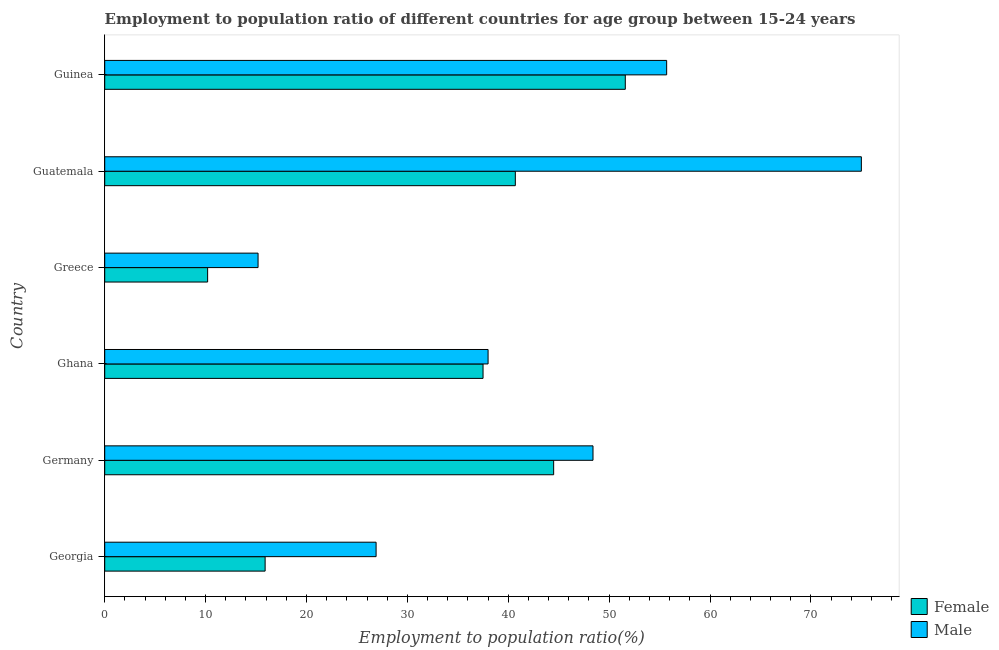Are the number of bars per tick equal to the number of legend labels?
Provide a succinct answer. Yes. What is the label of the 2nd group of bars from the top?
Keep it short and to the point. Guatemala. What is the employment to population ratio(female) in Guatemala?
Provide a succinct answer. 40.7. Across all countries, what is the maximum employment to population ratio(female)?
Keep it short and to the point. 51.6. Across all countries, what is the minimum employment to population ratio(male)?
Keep it short and to the point. 15.2. In which country was the employment to population ratio(male) maximum?
Keep it short and to the point. Guatemala. What is the total employment to population ratio(female) in the graph?
Your response must be concise. 200.4. What is the difference between the employment to population ratio(male) in Greece and that in Guatemala?
Your answer should be compact. -59.8. What is the difference between the employment to population ratio(female) in Georgia and the employment to population ratio(male) in Germany?
Offer a very short reply. -32.5. What is the average employment to population ratio(male) per country?
Offer a terse response. 43.2. What is the difference between the employment to population ratio(male) and employment to population ratio(female) in Germany?
Ensure brevity in your answer.  3.9. In how many countries, is the employment to population ratio(male) greater than 50 %?
Keep it short and to the point. 2. What is the ratio of the employment to population ratio(female) in Georgia to that in Greece?
Give a very brief answer. 1.56. Is the employment to population ratio(female) in Georgia less than that in Guinea?
Your answer should be compact. Yes. Is the difference between the employment to population ratio(male) in Ghana and Guatemala greater than the difference between the employment to population ratio(female) in Ghana and Guatemala?
Your answer should be compact. No. What is the difference between the highest and the second highest employment to population ratio(male)?
Keep it short and to the point. 19.3. What is the difference between the highest and the lowest employment to population ratio(male)?
Your response must be concise. 59.8. Is the sum of the employment to population ratio(male) in Georgia and Greece greater than the maximum employment to population ratio(female) across all countries?
Your response must be concise. No. What does the 2nd bar from the top in Germany represents?
Keep it short and to the point. Female. What does the 1st bar from the bottom in Ghana represents?
Give a very brief answer. Female. How many countries are there in the graph?
Your response must be concise. 6. What is the difference between two consecutive major ticks on the X-axis?
Keep it short and to the point. 10. Does the graph contain grids?
Offer a very short reply. No. How are the legend labels stacked?
Your answer should be very brief. Vertical. What is the title of the graph?
Give a very brief answer. Employment to population ratio of different countries for age group between 15-24 years. Does "Register a property" appear as one of the legend labels in the graph?
Provide a succinct answer. No. What is the label or title of the X-axis?
Your answer should be very brief. Employment to population ratio(%). What is the label or title of the Y-axis?
Give a very brief answer. Country. What is the Employment to population ratio(%) of Female in Georgia?
Ensure brevity in your answer.  15.9. What is the Employment to population ratio(%) in Male in Georgia?
Offer a terse response. 26.9. What is the Employment to population ratio(%) of Female in Germany?
Your response must be concise. 44.5. What is the Employment to population ratio(%) in Male in Germany?
Keep it short and to the point. 48.4. What is the Employment to population ratio(%) of Female in Ghana?
Your answer should be compact. 37.5. What is the Employment to population ratio(%) of Male in Ghana?
Your answer should be compact. 38. What is the Employment to population ratio(%) in Female in Greece?
Make the answer very short. 10.2. What is the Employment to population ratio(%) of Male in Greece?
Ensure brevity in your answer.  15.2. What is the Employment to population ratio(%) in Female in Guatemala?
Your response must be concise. 40.7. What is the Employment to population ratio(%) in Male in Guatemala?
Offer a very short reply. 75. What is the Employment to population ratio(%) in Female in Guinea?
Ensure brevity in your answer.  51.6. What is the Employment to population ratio(%) in Male in Guinea?
Provide a succinct answer. 55.7. Across all countries, what is the maximum Employment to population ratio(%) of Female?
Your response must be concise. 51.6. Across all countries, what is the minimum Employment to population ratio(%) of Female?
Ensure brevity in your answer.  10.2. Across all countries, what is the minimum Employment to population ratio(%) in Male?
Ensure brevity in your answer.  15.2. What is the total Employment to population ratio(%) in Female in the graph?
Provide a succinct answer. 200.4. What is the total Employment to population ratio(%) in Male in the graph?
Make the answer very short. 259.2. What is the difference between the Employment to population ratio(%) of Female in Georgia and that in Germany?
Your response must be concise. -28.6. What is the difference between the Employment to population ratio(%) of Male in Georgia and that in Germany?
Provide a succinct answer. -21.5. What is the difference between the Employment to population ratio(%) of Female in Georgia and that in Ghana?
Ensure brevity in your answer.  -21.6. What is the difference between the Employment to population ratio(%) in Male in Georgia and that in Ghana?
Keep it short and to the point. -11.1. What is the difference between the Employment to population ratio(%) of Male in Georgia and that in Greece?
Offer a very short reply. 11.7. What is the difference between the Employment to population ratio(%) of Female in Georgia and that in Guatemala?
Offer a terse response. -24.8. What is the difference between the Employment to population ratio(%) in Male in Georgia and that in Guatemala?
Your response must be concise. -48.1. What is the difference between the Employment to population ratio(%) in Female in Georgia and that in Guinea?
Offer a very short reply. -35.7. What is the difference between the Employment to population ratio(%) in Male in Georgia and that in Guinea?
Offer a terse response. -28.8. What is the difference between the Employment to population ratio(%) in Female in Germany and that in Ghana?
Give a very brief answer. 7. What is the difference between the Employment to population ratio(%) of Male in Germany and that in Ghana?
Offer a very short reply. 10.4. What is the difference between the Employment to population ratio(%) of Female in Germany and that in Greece?
Provide a short and direct response. 34.3. What is the difference between the Employment to population ratio(%) in Male in Germany and that in Greece?
Provide a short and direct response. 33.2. What is the difference between the Employment to population ratio(%) in Female in Germany and that in Guatemala?
Provide a short and direct response. 3.8. What is the difference between the Employment to population ratio(%) of Male in Germany and that in Guatemala?
Keep it short and to the point. -26.6. What is the difference between the Employment to population ratio(%) of Female in Germany and that in Guinea?
Your answer should be very brief. -7.1. What is the difference between the Employment to population ratio(%) in Male in Germany and that in Guinea?
Make the answer very short. -7.3. What is the difference between the Employment to population ratio(%) of Female in Ghana and that in Greece?
Ensure brevity in your answer.  27.3. What is the difference between the Employment to population ratio(%) in Male in Ghana and that in Greece?
Ensure brevity in your answer.  22.8. What is the difference between the Employment to population ratio(%) in Female in Ghana and that in Guatemala?
Your answer should be very brief. -3.2. What is the difference between the Employment to population ratio(%) in Male in Ghana and that in Guatemala?
Your response must be concise. -37. What is the difference between the Employment to population ratio(%) in Female in Ghana and that in Guinea?
Keep it short and to the point. -14.1. What is the difference between the Employment to population ratio(%) in Male in Ghana and that in Guinea?
Keep it short and to the point. -17.7. What is the difference between the Employment to population ratio(%) in Female in Greece and that in Guatemala?
Your response must be concise. -30.5. What is the difference between the Employment to population ratio(%) of Male in Greece and that in Guatemala?
Offer a terse response. -59.8. What is the difference between the Employment to population ratio(%) of Female in Greece and that in Guinea?
Provide a short and direct response. -41.4. What is the difference between the Employment to population ratio(%) of Male in Greece and that in Guinea?
Provide a succinct answer. -40.5. What is the difference between the Employment to population ratio(%) in Female in Guatemala and that in Guinea?
Offer a terse response. -10.9. What is the difference between the Employment to population ratio(%) of Male in Guatemala and that in Guinea?
Make the answer very short. 19.3. What is the difference between the Employment to population ratio(%) in Female in Georgia and the Employment to population ratio(%) in Male in Germany?
Offer a terse response. -32.5. What is the difference between the Employment to population ratio(%) in Female in Georgia and the Employment to population ratio(%) in Male in Ghana?
Give a very brief answer. -22.1. What is the difference between the Employment to population ratio(%) of Female in Georgia and the Employment to population ratio(%) of Male in Greece?
Make the answer very short. 0.7. What is the difference between the Employment to population ratio(%) of Female in Georgia and the Employment to population ratio(%) of Male in Guatemala?
Your answer should be compact. -59.1. What is the difference between the Employment to population ratio(%) of Female in Georgia and the Employment to population ratio(%) of Male in Guinea?
Give a very brief answer. -39.8. What is the difference between the Employment to population ratio(%) of Female in Germany and the Employment to population ratio(%) of Male in Greece?
Offer a terse response. 29.3. What is the difference between the Employment to population ratio(%) in Female in Germany and the Employment to population ratio(%) in Male in Guatemala?
Your response must be concise. -30.5. What is the difference between the Employment to population ratio(%) of Female in Ghana and the Employment to population ratio(%) of Male in Greece?
Offer a very short reply. 22.3. What is the difference between the Employment to population ratio(%) of Female in Ghana and the Employment to population ratio(%) of Male in Guatemala?
Keep it short and to the point. -37.5. What is the difference between the Employment to population ratio(%) of Female in Ghana and the Employment to population ratio(%) of Male in Guinea?
Your response must be concise. -18.2. What is the difference between the Employment to population ratio(%) in Female in Greece and the Employment to population ratio(%) in Male in Guatemala?
Ensure brevity in your answer.  -64.8. What is the difference between the Employment to population ratio(%) of Female in Greece and the Employment to population ratio(%) of Male in Guinea?
Offer a terse response. -45.5. What is the difference between the Employment to population ratio(%) in Female in Guatemala and the Employment to population ratio(%) in Male in Guinea?
Your response must be concise. -15. What is the average Employment to population ratio(%) in Female per country?
Provide a succinct answer. 33.4. What is the average Employment to population ratio(%) in Male per country?
Keep it short and to the point. 43.2. What is the difference between the Employment to population ratio(%) of Female and Employment to population ratio(%) of Male in Ghana?
Make the answer very short. -0.5. What is the difference between the Employment to population ratio(%) in Female and Employment to population ratio(%) in Male in Guatemala?
Offer a terse response. -34.3. What is the difference between the Employment to population ratio(%) of Female and Employment to population ratio(%) of Male in Guinea?
Your answer should be very brief. -4.1. What is the ratio of the Employment to population ratio(%) in Female in Georgia to that in Germany?
Keep it short and to the point. 0.36. What is the ratio of the Employment to population ratio(%) of Male in Georgia to that in Germany?
Your answer should be very brief. 0.56. What is the ratio of the Employment to population ratio(%) of Female in Georgia to that in Ghana?
Offer a very short reply. 0.42. What is the ratio of the Employment to population ratio(%) in Male in Georgia to that in Ghana?
Offer a very short reply. 0.71. What is the ratio of the Employment to population ratio(%) of Female in Georgia to that in Greece?
Offer a terse response. 1.56. What is the ratio of the Employment to population ratio(%) in Male in Georgia to that in Greece?
Give a very brief answer. 1.77. What is the ratio of the Employment to population ratio(%) in Female in Georgia to that in Guatemala?
Offer a very short reply. 0.39. What is the ratio of the Employment to population ratio(%) of Male in Georgia to that in Guatemala?
Your response must be concise. 0.36. What is the ratio of the Employment to population ratio(%) in Female in Georgia to that in Guinea?
Make the answer very short. 0.31. What is the ratio of the Employment to population ratio(%) of Male in Georgia to that in Guinea?
Provide a short and direct response. 0.48. What is the ratio of the Employment to population ratio(%) in Female in Germany to that in Ghana?
Give a very brief answer. 1.19. What is the ratio of the Employment to population ratio(%) in Male in Germany to that in Ghana?
Keep it short and to the point. 1.27. What is the ratio of the Employment to population ratio(%) in Female in Germany to that in Greece?
Make the answer very short. 4.36. What is the ratio of the Employment to population ratio(%) of Male in Germany to that in Greece?
Your response must be concise. 3.18. What is the ratio of the Employment to population ratio(%) of Female in Germany to that in Guatemala?
Your response must be concise. 1.09. What is the ratio of the Employment to population ratio(%) of Male in Germany to that in Guatemala?
Your answer should be very brief. 0.65. What is the ratio of the Employment to population ratio(%) in Female in Germany to that in Guinea?
Your answer should be very brief. 0.86. What is the ratio of the Employment to population ratio(%) of Male in Germany to that in Guinea?
Your response must be concise. 0.87. What is the ratio of the Employment to population ratio(%) in Female in Ghana to that in Greece?
Offer a very short reply. 3.68. What is the ratio of the Employment to population ratio(%) in Male in Ghana to that in Greece?
Make the answer very short. 2.5. What is the ratio of the Employment to population ratio(%) of Female in Ghana to that in Guatemala?
Ensure brevity in your answer.  0.92. What is the ratio of the Employment to population ratio(%) in Male in Ghana to that in Guatemala?
Your response must be concise. 0.51. What is the ratio of the Employment to population ratio(%) in Female in Ghana to that in Guinea?
Provide a succinct answer. 0.73. What is the ratio of the Employment to population ratio(%) in Male in Ghana to that in Guinea?
Your answer should be compact. 0.68. What is the ratio of the Employment to population ratio(%) of Female in Greece to that in Guatemala?
Your answer should be very brief. 0.25. What is the ratio of the Employment to population ratio(%) in Male in Greece to that in Guatemala?
Provide a short and direct response. 0.2. What is the ratio of the Employment to population ratio(%) of Female in Greece to that in Guinea?
Ensure brevity in your answer.  0.2. What is the ratio of the Employment to population ratio(%) of Male in Greece to that in Guinea?
Make the answer very short. 0.27. What is the ratio of the Employment to population ratio(%) in Female in Guatemala to that in Guinea?
Provide a short and direct response. 0.79. What is the ratio of the Employment to population ratio(%) in Male in Guatemala to that in Guinea?
Offer a very short reply. 1.35. What is the difference between the highest and the second highest Employment to population ratio(%) in Female?
Provide a short and direct response. 7.1. What is the difference between the highest and the second highest Employment to population ratio(%) in Male?
Keep it short and to the point. 19.3. What is the difference between the highest and the lowest Employment to population ratio(%) in Female?
Keep it short and to the point. 41.4. What is the difference between the highest and the lowest Employment to population ratio(%) in Male?
Provide a succinct answer. 59.8. 